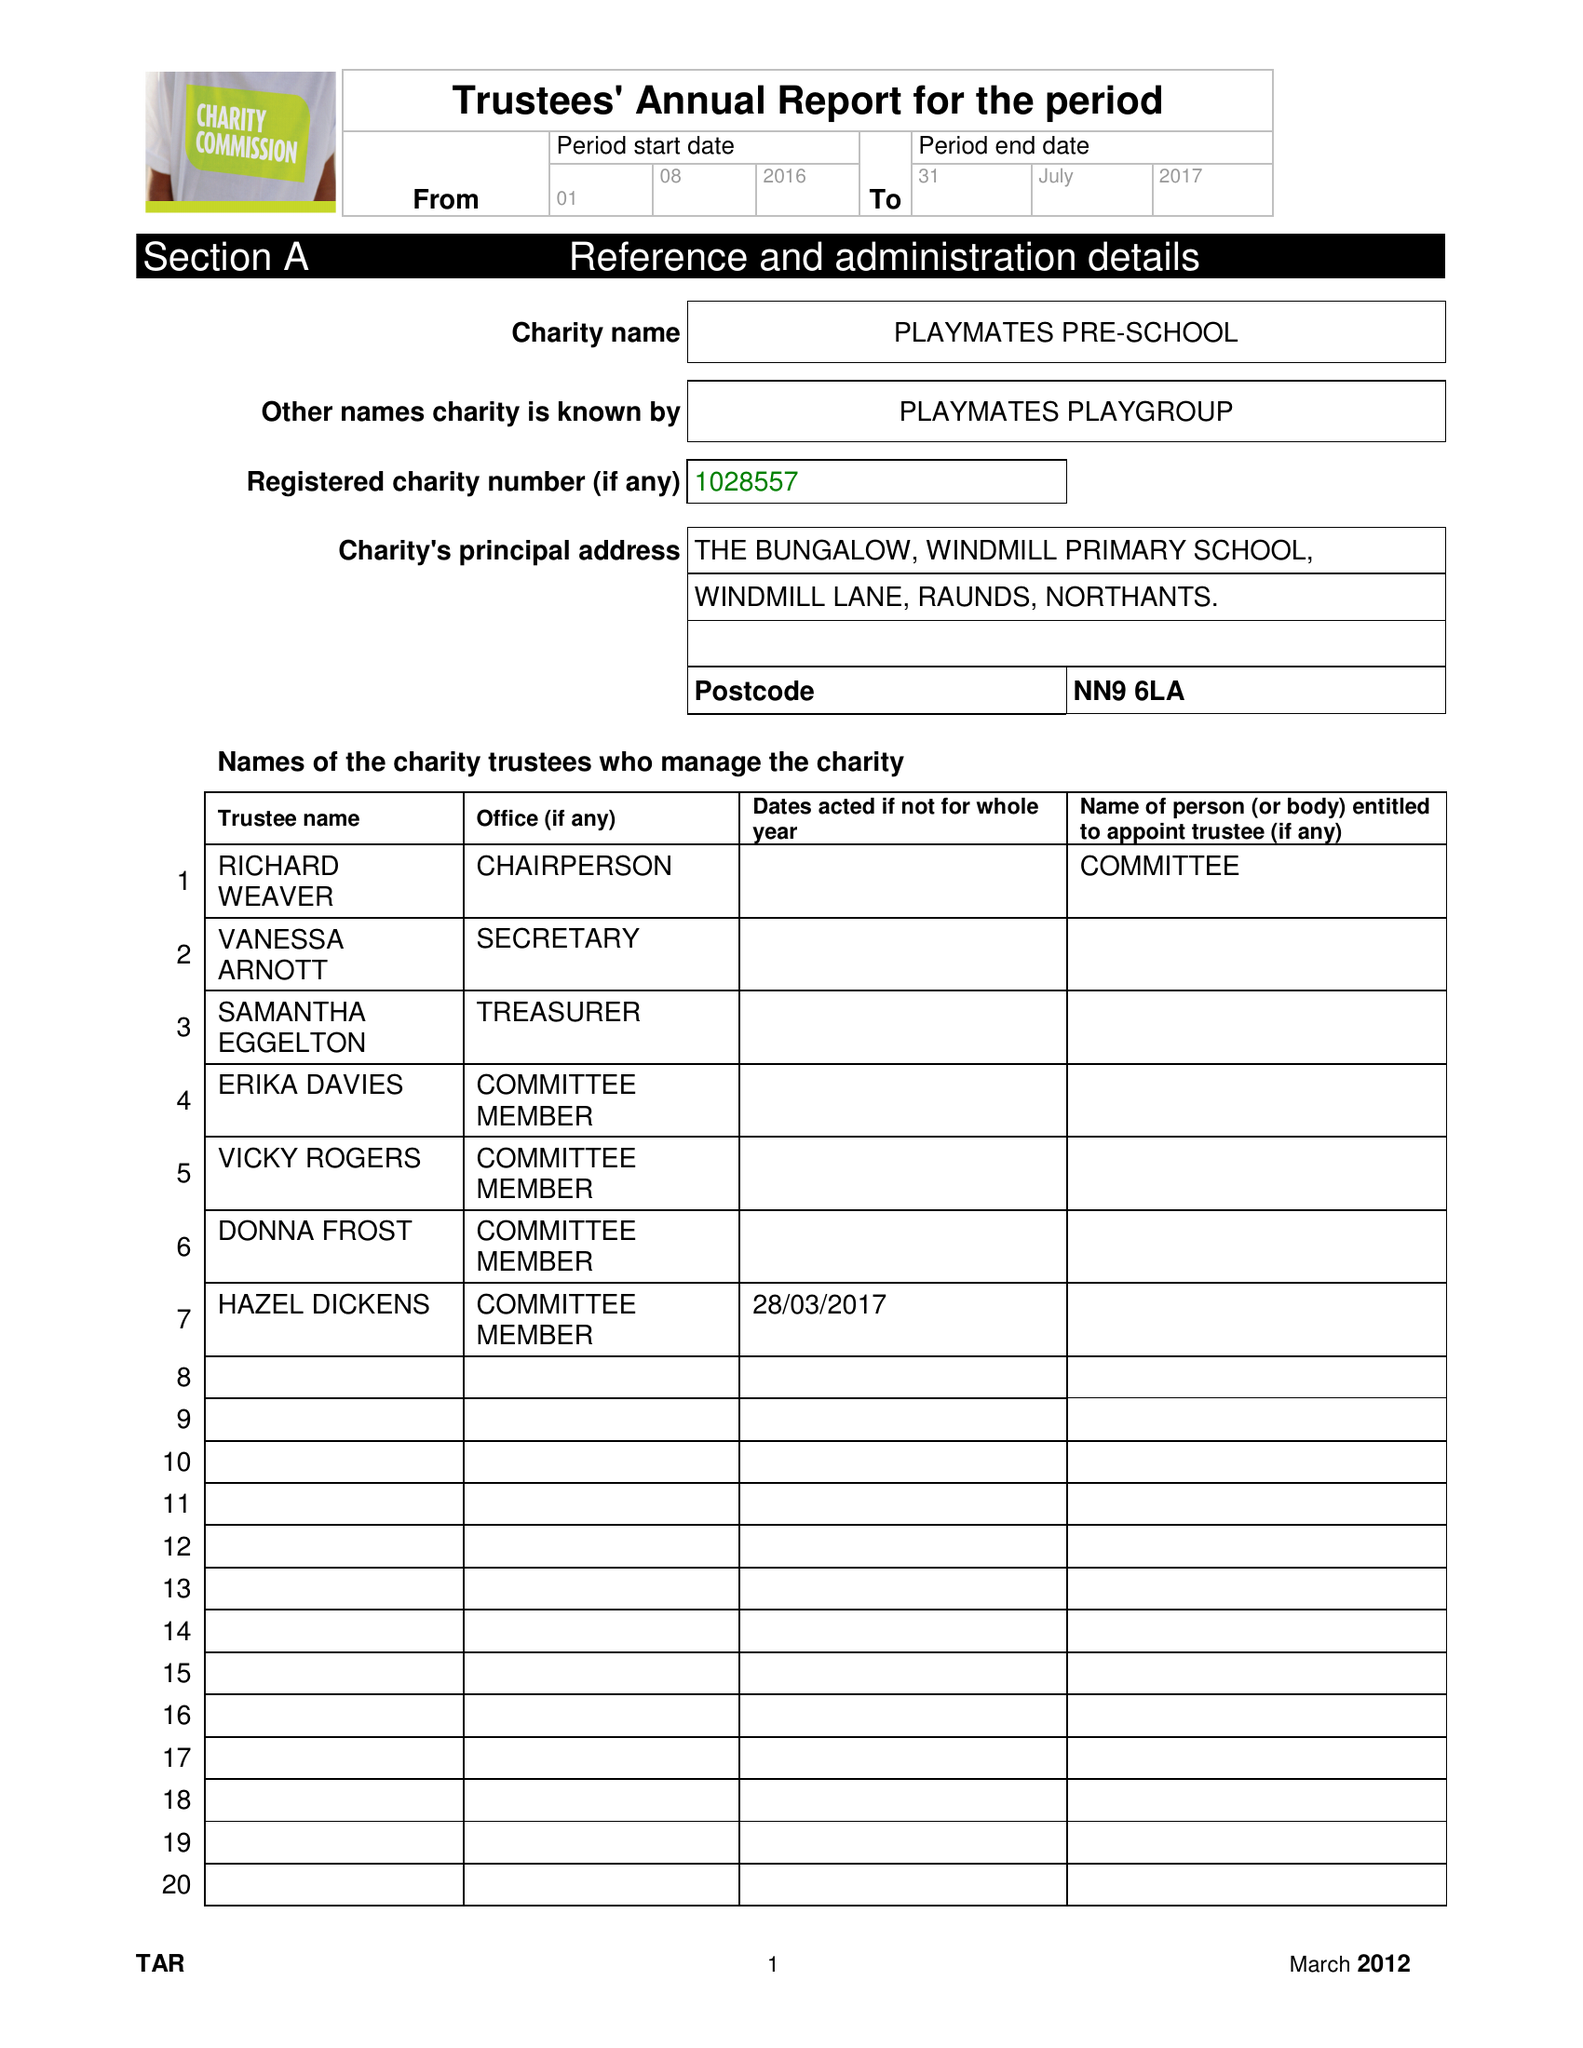What is the value for the report_date?
Answer the question using a single word or phrase. 2017-07-31 